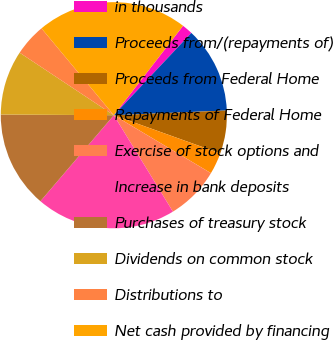Convert chart to OTSL. <chart><loc_0><loc_0><loc_500><loc_500><pie_chart><fcel>in thousands<fcel>Proceeds from/(repayments of)<fcel>Proceeds from Federal Home<fcel>Repayments of Federal Home<fcel>Exercise of stock options and<fcel>Increase in bank deposits<fcel>Purchases of treasury stock<fcel>Dividends on common stock<fcel>Distributions to<fcel>Net cash provided by financing<nl><fcel>1.54%<fcel>12.31%<fcel>6.15%<fcel>3.08%<fcel>7.69%<fcel>20.0%<fcel>13.85%<fcel>9.23%<fcel>4.62%<fcel>21.54%<nl></chart> 